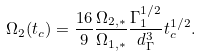Convert formula to latex. <formula><loc_0><loc_0><loc_500><loc_500>\Omega _ { 2 } ( t _ { c } ) = \frac { 1 6 } { 9 } \frac { \Omega _ { 2 , * } } { \Omega _ { 1 , * } } \frac { \Gamma _ { 1 } ^ { 1 / 2 } } { d _ { \Gamma } ^ { 3 } } t _ { c } ^ { 1 / 2 } .</formula> 